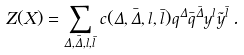<formula> <loc_0><loc_0><loc_500><loc_500>Z ( X ) = \sum _ { \Delta , \bar { \Delta } , l , \bar { l } } c ( \Delta , \bar { \Delta } , l , \bar { l } ) q ^ { \Delta } \bar { q } ^ { \bar { \Delta } } y ^ { l } \tilde { y } ^ { \bar { l } } \, .</formula> 